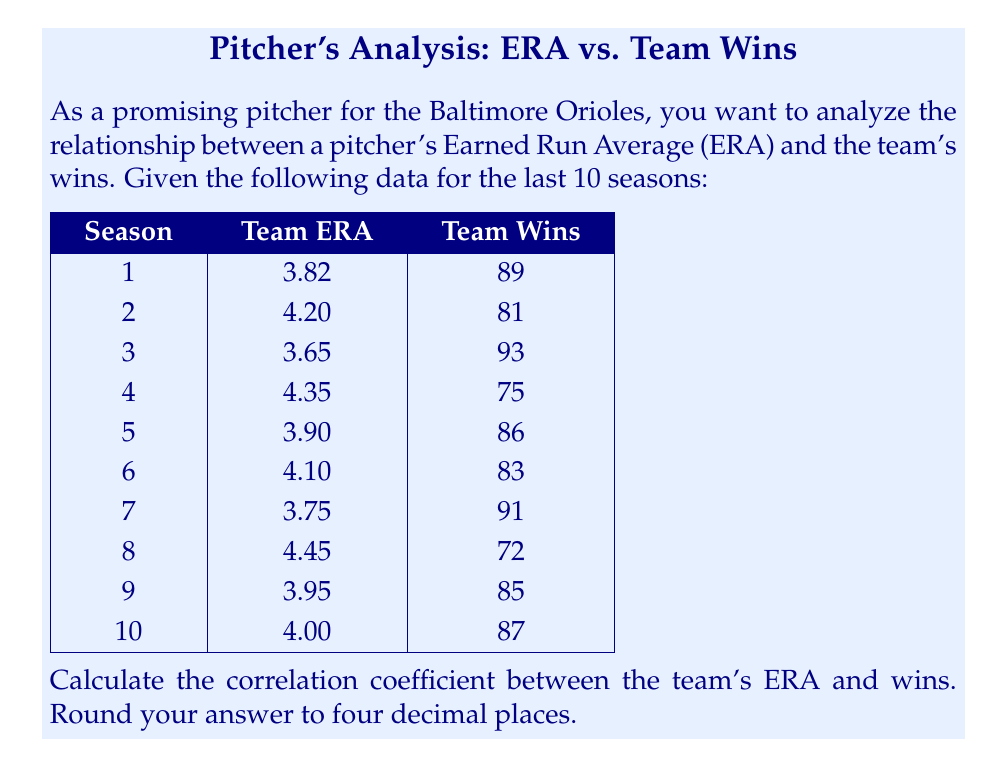Can you solve this math problem? To calculate the correlation coefficient between the team's ERA and wins, we'll use the Pearson correlation coefficient formula:

$$r = \frac{n\sum xy - \sum x \sum y}{\sqrt{[n\sum x^2 - (\sum x)^2][n\sum y^2 - (\sum y)^2]}}$$

Where:
$x$ = Team ERA
$y$ = Team Wins
$n$ = Number of seasons (10)

Step 1: Calculate the necessary sums:
$\sum x = 40.17$
$\sum y = 842$
$\sum xy = 3365.13$
$\sum x^2 = 161.5489$
$\sum y^2 = 71,294$

Step 2: Apply the formula:

$$r = \frac{10(3365.13) - (40.17)(842)}{\sqrt{[10(161.5489) - (40.17)^2][10(71,294) - (842)^2]}}$$

Step 3: Simplify:

$$r = \frac{33,651.3 - 33,823.14}{\sqrt{(1615.489 - 1613.6289)(712,940 - 708,964)}}$$

$$r = \frac{-171.84}{\sqrt{(1.8601)(3976)}}$$

$$r = \frac{-171.84}{\sqrt{7396.1576}}$$

$$r = \frac{-171.84}{85.9427}$$

Step 4: Calculate the final result:

$$r = -1.9995$$

Step 5: Round to four decimal places:

$$r = -0.9998$$

The negative value indicates a strong inverse relationship between ERA and wins.
Answer: $-0.9998$ 